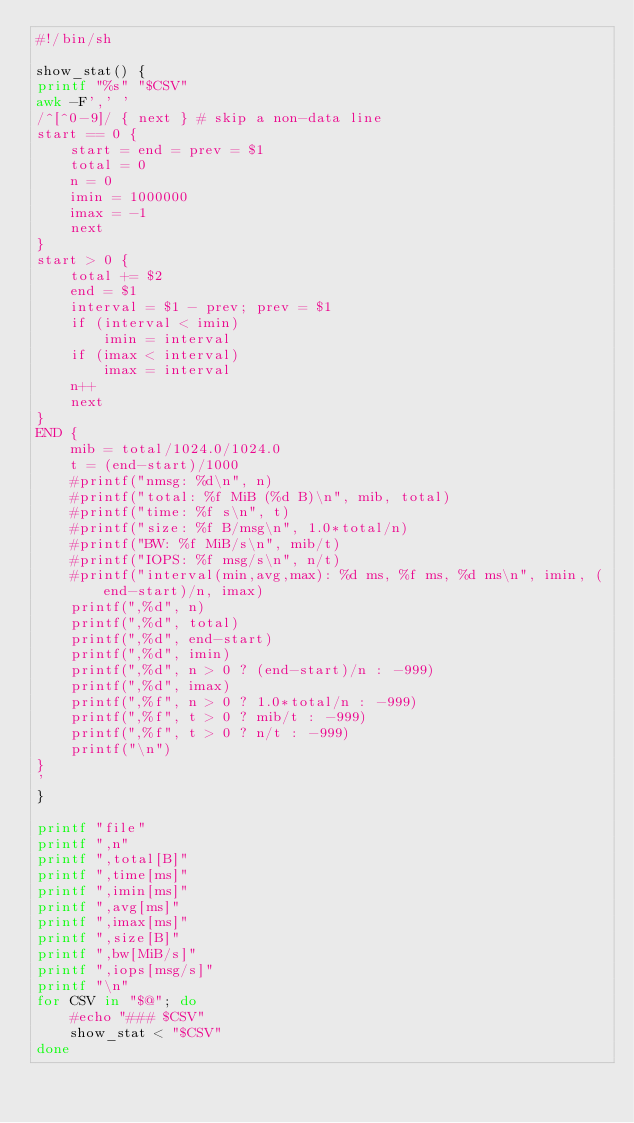<code> <loc_0><loc_0><loc_500><loc_500><_Bash_>#!/bin/sh

show_stat() {
printf "%s" "$CSV"
awk -F',' '
/^[^0-9]/ { next } # skip a non-data line
start == 0 {
    start = end = prev = $1
    total = 0
    n = 0
    imin = 1000000
    imax = -1
    next
}
start > 0 {
    total += $2
    end = $1
    interval = $1 - prev; prev = $1
    if (interval < imin)
        imin = interval
    if (imax < interval)
        imax = interval
    n++
    next
}
END {
    mib = total/1024.0/1024.0
    t = (end-start)/1000
    #printf("nmsg: %d\n", n)
    #printf("total: %f MiB (%d B)\n", mib, total)
    #printf("time: %f s\n", t)
    #printf("size: %f B/msg\n", 1.0*total/n)
    #printf("BW: %f MiB/s\n", mib/t)
    #printf("IOPS: %f msg/s\n", n/t)
    #printf("interval(min,avg,max): %d ms, %f ms, %d ms\n", imin, (end-start)/n, imax)
    printf(",%d", n)
    printf(",%d", total)
    printf(",%d", end-start)
    printf(",%d", imin)
    printf(",%d", n > 0 ? (end-start)/n : -999)
    printf(",%d", imax)
    printf(",%f", n > 0 ? 1.0*total/n : -999)
    printf(",%f", t > 0 ? mib/t : -999)
    printf(",%f", t > 0 ? n/t : -999)
    printf("\n")
}
'
}

printf "file"
printf ",n"
printf ",total[B]"
printf ",time[ms]"
printf ",imin[ms]"
printf ",avg[ms]"
printf ",imax[ms]"
printf ",size[B]"
printf ",bw[MiB/s]"
printf ",iops[msg/s]"
printf "\n"
for CSV in "$@"; do
    #echo "### $CSV"
    show_stat < "$CSV"
done
</code> 